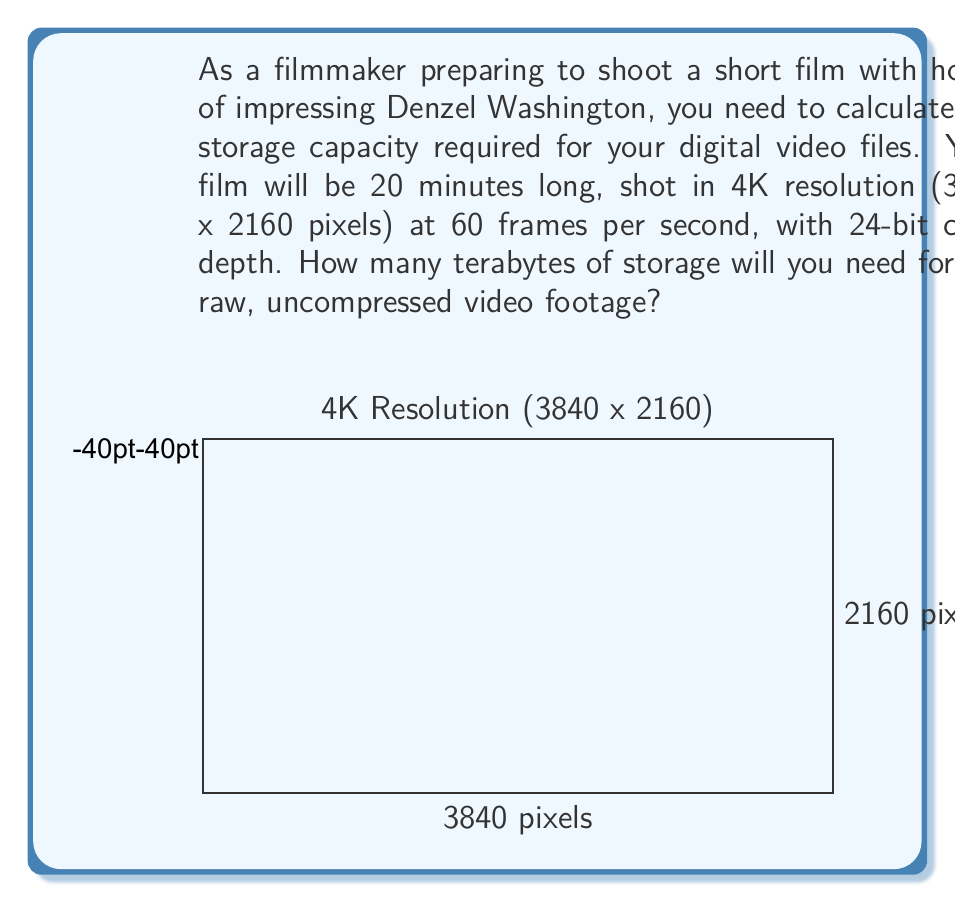What is the answer to this math problem? Let's break this down step-by-step:

1) First, calculate the number of pixels per frame:
   $3840 \times 2160 = 8,294,400$ pixels

2) Each pixel uses 24 bits (3 bytes) of color information:
   $8,294,400 \times 3 = 24,883,200$ bytes per frame

3) The video runs at 60 frames per second (fps):
   $24,883,200 \times 60 = 1,492,992,000$ bytes per second

4) The film is 20 minutes long, so calculate total bytes:
   $1,492,992,000 \times (20 \times 60) = 1,791,590,400,000$ bytes

5) Convert bytes to terabytes:
   $$\frac{1,791,590,400,000}{1,099,511,627,776} \approx 1.63$$ terabytes

6) In binary, 1 terabyte is $2^{40}$ bytes. So the result in binary is approximately:
   $$1.63 \times 2^{40} \approx 1.63 \times (1 \text{ followed by 40 zeros in binary})$$

Therefore, you'll need approximately 1.63 terabytes of storage for your raw, uncompressed 4K video footage.
Answer: $1.63$ TB or $1.63 \times 2^{40}$ bytes 